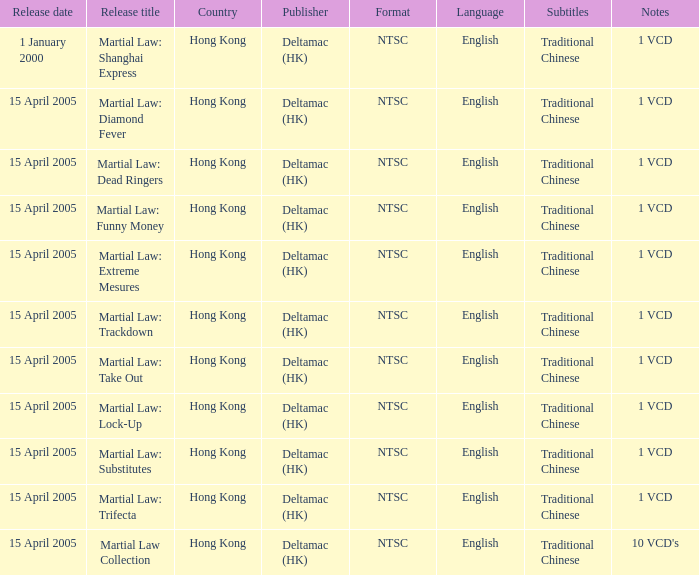What is the launch date of martial law: take out? 15 April 2005. 